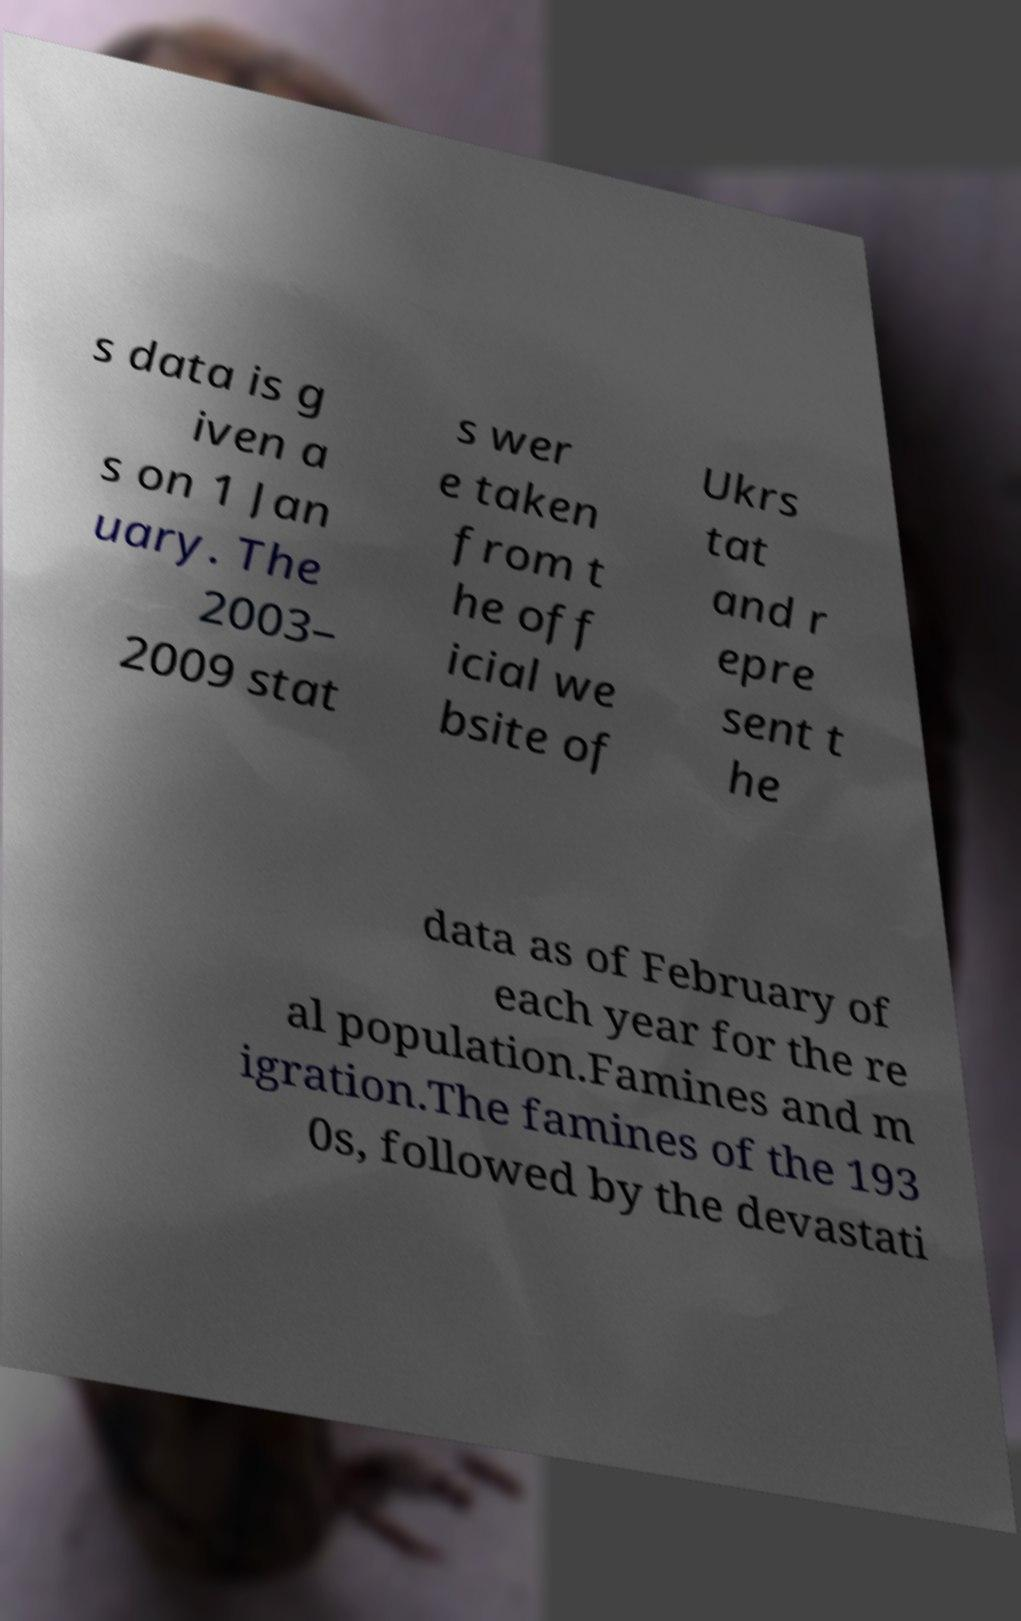Can you read and provide the text displayed in the image?This photo seems to have some interesting text. Can you extract and type it out for me? s data is g iven a s on 1 Jan uary. The 2003– 2009 stat s wer e taken from t he off icial we bsite of Ukrs tat and r epre sent t he data as of February of each year for the re al population.Famines and m igration.The famines of the 193 0s, followed by the devastati 